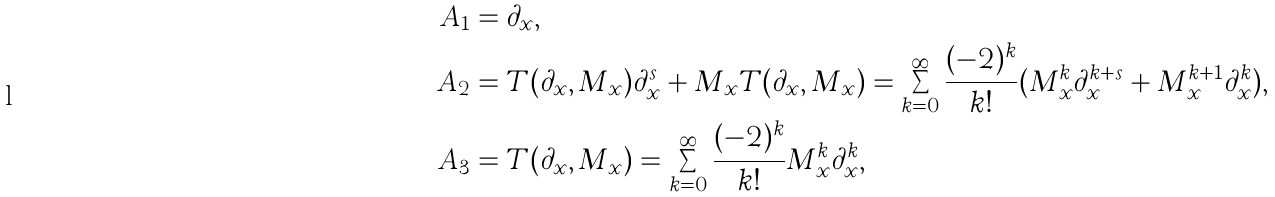<formula> <loc_0><loc_0><loc_500><loc_500>A _ { 1 } & = \partial _ { x } , \\ A _ { 2 } & = T ( \partial _ { x } , M _ { x } ) \partial _ { x } ^ { s } + M _ { x } T ( \partial _ { x } , M _ { x } ) = \sum _ { k = 0 } ^ { \infty } \frac { ( - 2 ) ^ { k } } { k ! } ( M _ { x } ^ { k } \partial _ { x } ^ { k + s } + M _ { x } ^ { k + 1 } \partial _ { x } ^ { k } ) , \\ A _ { 3 } & = T ( \partial _ { x } , M _ { x } ) = \sum _ { k = 0 } ^ { \infty } \frac { ( - 2 ) ^ { k } } { k ! } M _ { x } ^ { k } \partial _ { x } ^ { k } ,</formula> 